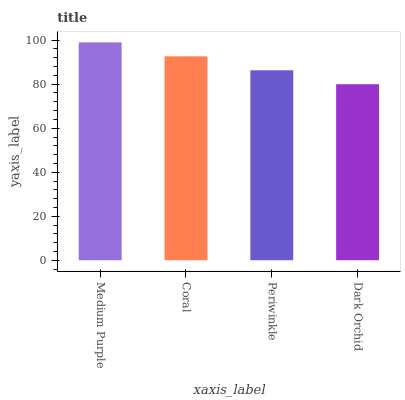Is Coral the minimum?
Answer yes or no. No. Is Coral the maximum?
Answer yes or no. No. Is Medium Purple greater than Coral?
Answer yes or no. Yes. Is Coral less than Medium Purple?
Answer yes or no. Yes. Is Coral greater than Medium Purple?
Answer yes or no. No. Is Medium Purple less than Coral?
Answer yes or no. No. Is Coral the high median?
Answer yes or no. Yes. Is Periwinkle the low median?
Answer yes or no. Yes. Is Medium Purple the high median?
Answer yes or no. No. Is Medium Purple the low median?
Answer yes or no. No. 